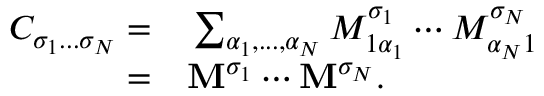<formula> <loc_0><loc_0><loc_500><loc_500>\begin{array} { r l } { C _ { \sigma _ { 1 } \dots \sigma _ { N } } = } & \sum _ { \alpha _ { 1 } , \dots , \alpha _ { N } } M _ { 1 \alpha _ { 1 } } ^ { \sigma _ { 1 } } \cdots M _ { \alpha _ { N } 1 } ^ { \sigma _ { N } } } \\ { = } & M ^ { \sigma _ { 1 } } \cdots M ^ { \sigma _ { N } } . } \end{array}</formula> 